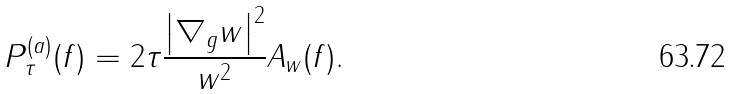Convert formula to latex. <formula><loc_0><loc_0><loc_500><loc_500>P _ { \tau } ^ { ( a ) } ( f ) = 2 \tau \frac { \left | \nabla _ { g } w \right | ^ { 2 } } { w ^ { 2 } } A _ { w } ( f ) .</formula> 